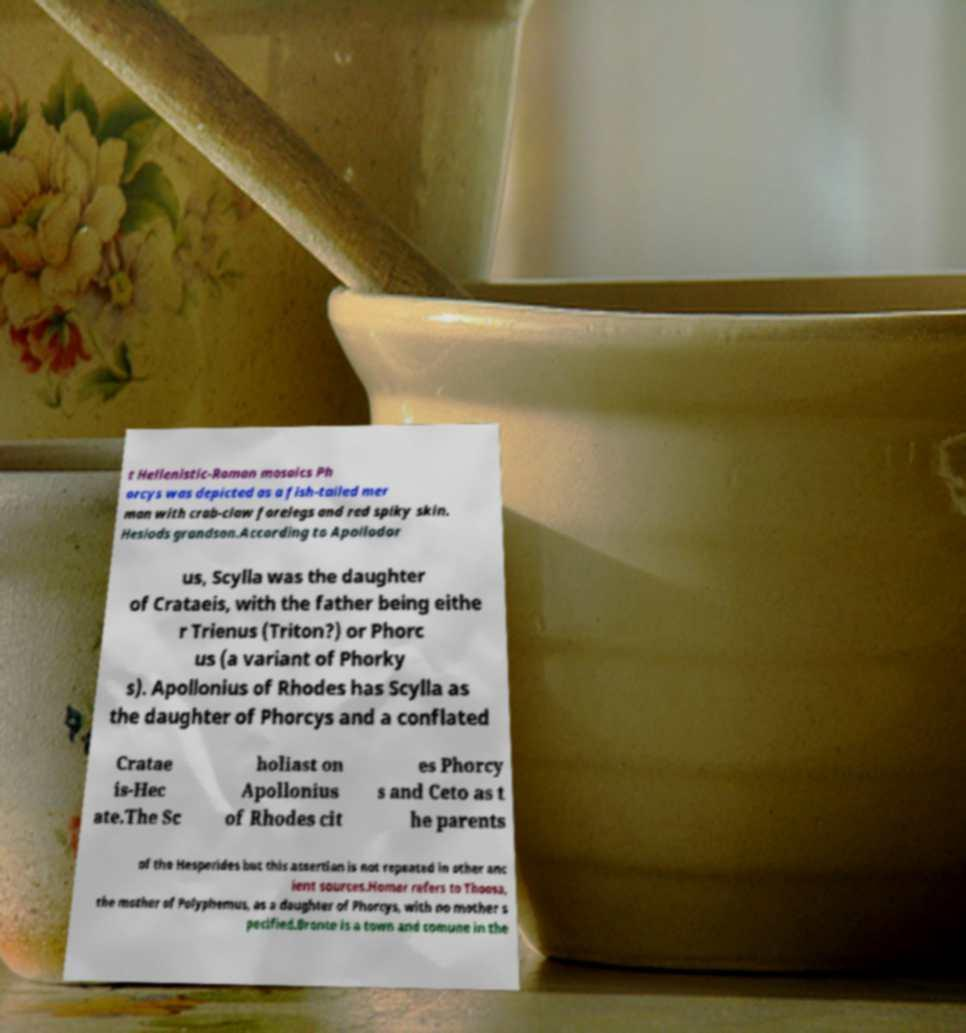What messages or text are displayed in this image? I need them in a readable, typed format. t Hellenistic-Roman mosaics Ph orcys was depicted as a fish-tailed mer man with crab-claw forelegs and red spiky skin. Hesiods grandson.According to Apollodor us, Scylla was the daughter of Crataeis, with the father being eithe r Trienus (Triton?) or Phorc us (a variant of Phorky s). Apollonius of Rhodes has Scylla as the daughter of Phorcys and a conflated Cratae is-Hec ate.The Sc holiast on Apollonius of Rhodes cit es Phorcy s and Ceto as t he parents of the Hesperides but this assertion is not repeated in other anc ient sources.Homer refers to Thoosa, the mother of Polyphemus, as a daughter of Phorcys, with no mother s pecified.Bronte is a town and comune in the 